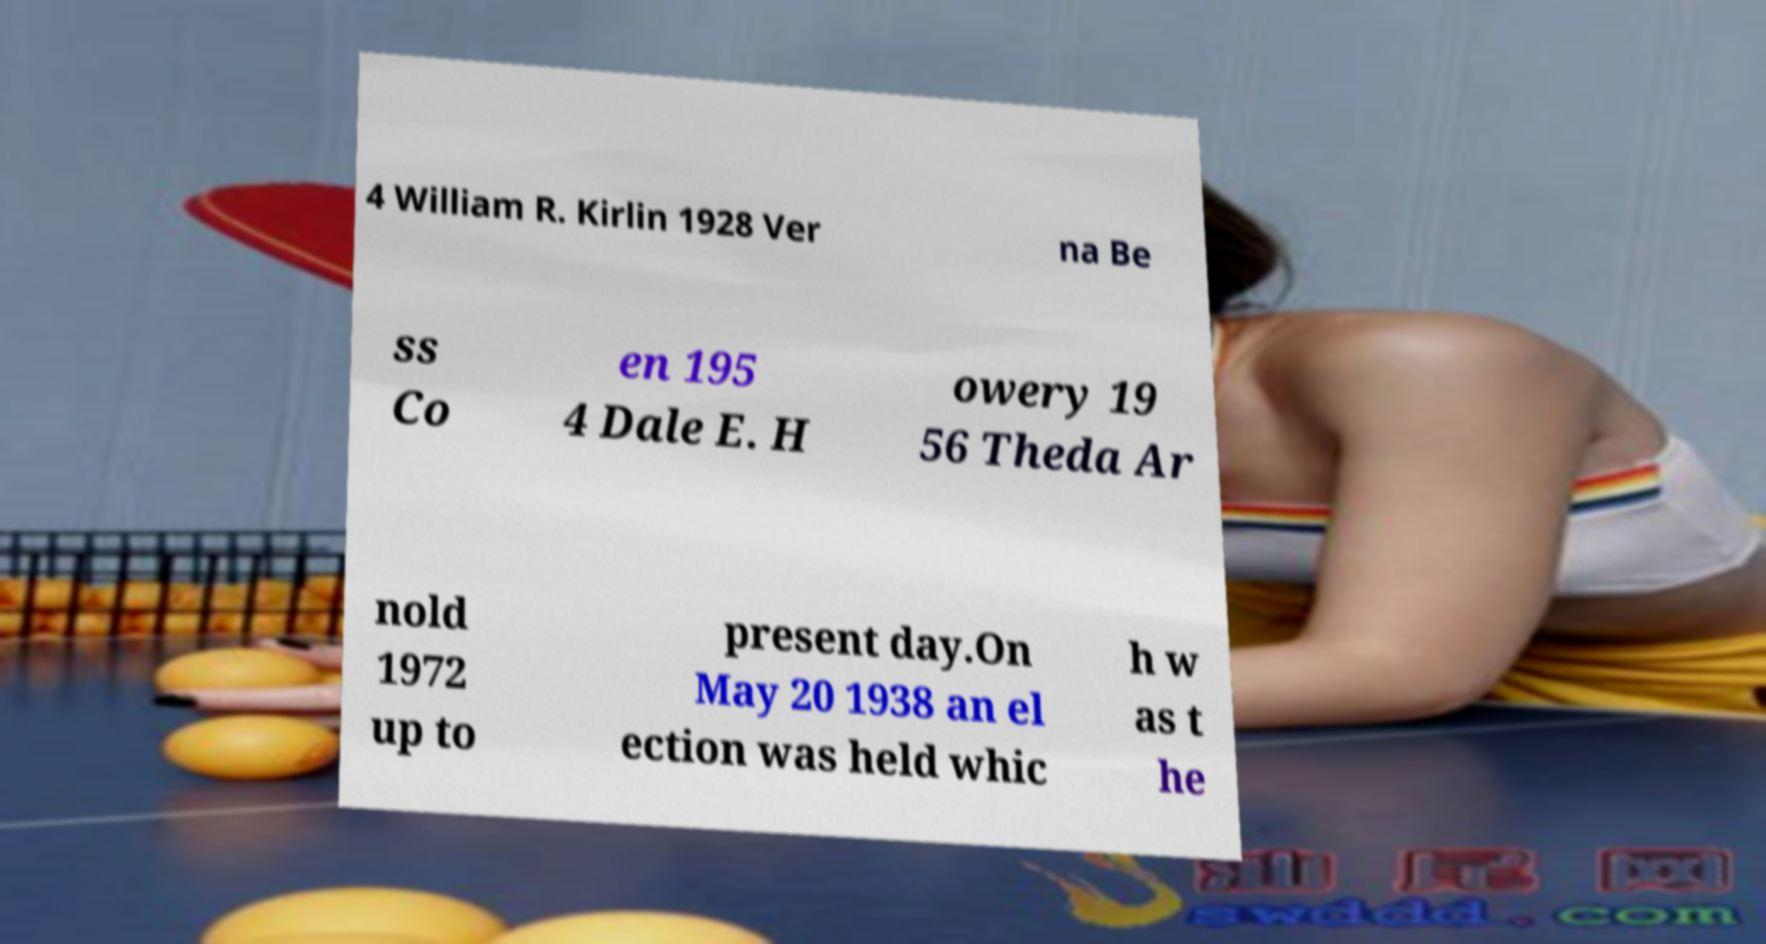Please identify and transcribe the text found in this image. 4 William R. Kirlin 1928 Ver na Be ss Co en 195 4 Dale E. H owery 19 56 Theda Ar nold 1972 up to present day.On May 20 1938 an el ection was held whic h w as t he 